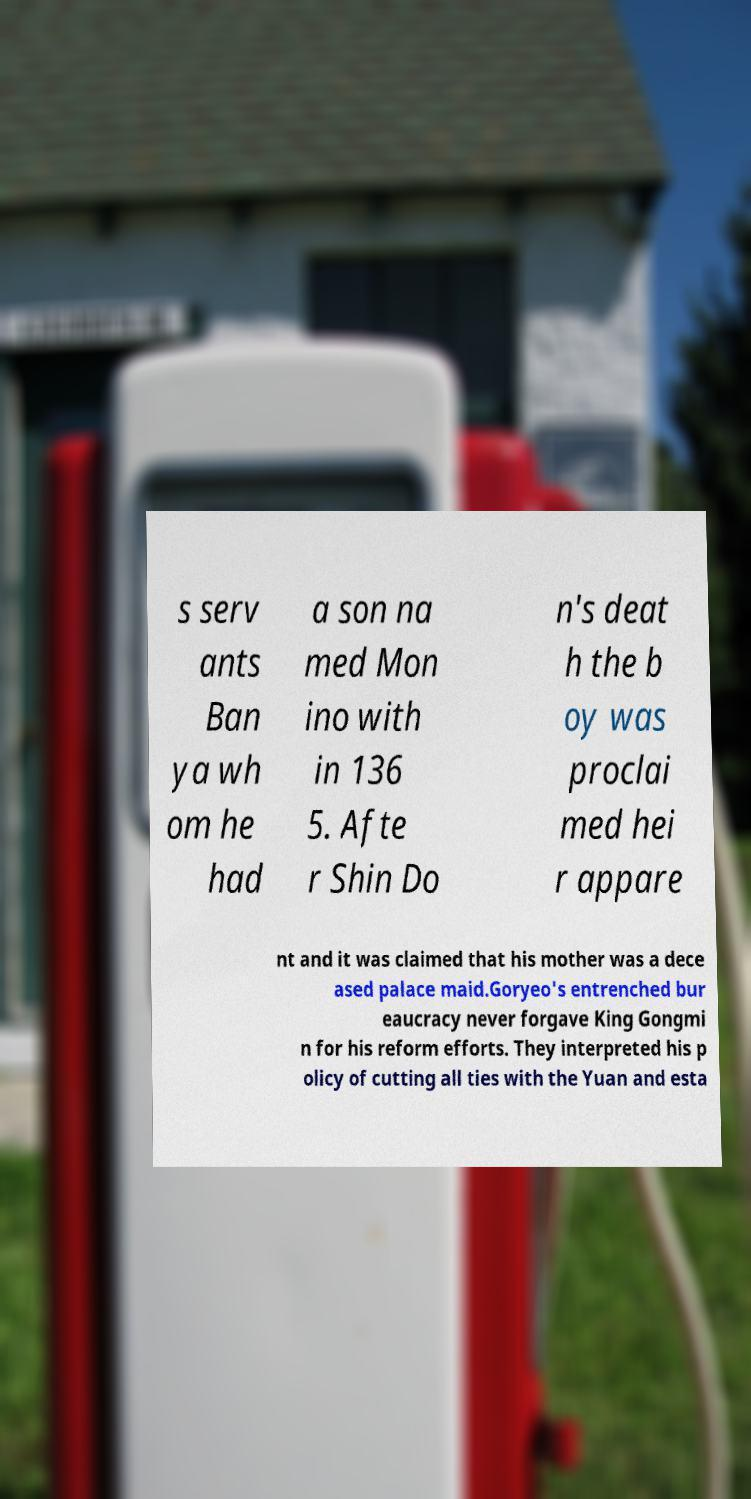I need the written content from this picture converted into text. Can you do that? s serv ants Ban ya wh om he had a son na med Mon ino with in 136 5. Afte r Shin Do n's deat h the b oy was proclai med hei r appare nt and it was claimed that his mother was a dece ased palace maid.Goryeo's entrenched bur eaucracy never forgave King Gongmi n for his reform efforts. They interpreted his p olicy of cutting all ties with the Yuan and esta 